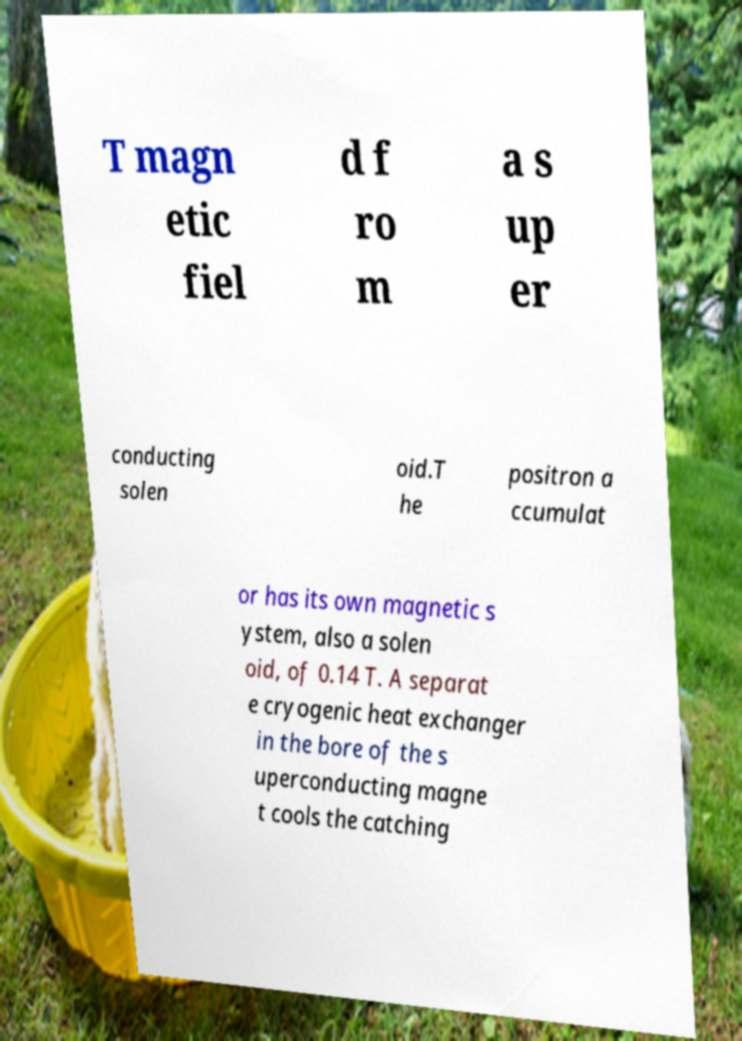I need the written content from this picture converted into text. Can you do that? T magn etic fiel d f ro m a s up er conducting solen oid.T he positron a ccumulat or has its own magnetic s ystem, also a solen oid, of 0.14 T. A separat e cryogenic heat exchanger in the bore of the s uperconducting magne t cools the catching 